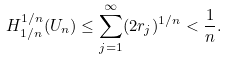Convert formula to latex. <formula><loc_0><loc_0><loc_500><loc_500>H ^ { 1 / n } _ { 1 / n } ( U _ { n } ) \leq \sum _ { j = 1 } ^ { \infty } ( 2 r _ { j } ) ^ { 1 / n } < \frac { 1 } { n } .</formula> 